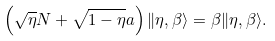<formula> <loc_0><loc_0><loc_500><loc_500>\left ( \sqrt { \eta } N + \sqrt { 1 - \eta } a \right ) \| \eta , \beta \rangle = \beta \| \eta , \beta \rangle .</formula> 